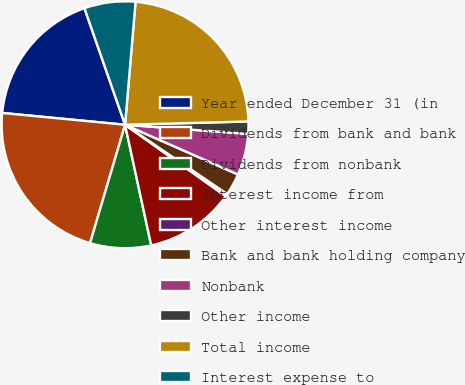Convert chart to OTSL. <chart><loc_0><loc_0><loc_500><loc_500><pie_chart><fcel>Year ended December 31 (in<fcel>Dividends from bank and bank<fcel>Dividends from nonbank<fcel>Interest income from<fcel>Other interest income<fcel>Bank and bank holding company<fcel>Nonbank<fcel>Other income<fcel>Total income<fcel>Interest expense to<nl><fcel>18.14%<fcel>21.95%<fcel>7.97%<fcel>11.78%<fcel>0.34%<fcel>2.88%<fcel>5.42%<fcel>1.61%<fcel>23.22%<fcel>6.69%<nl></chart> 